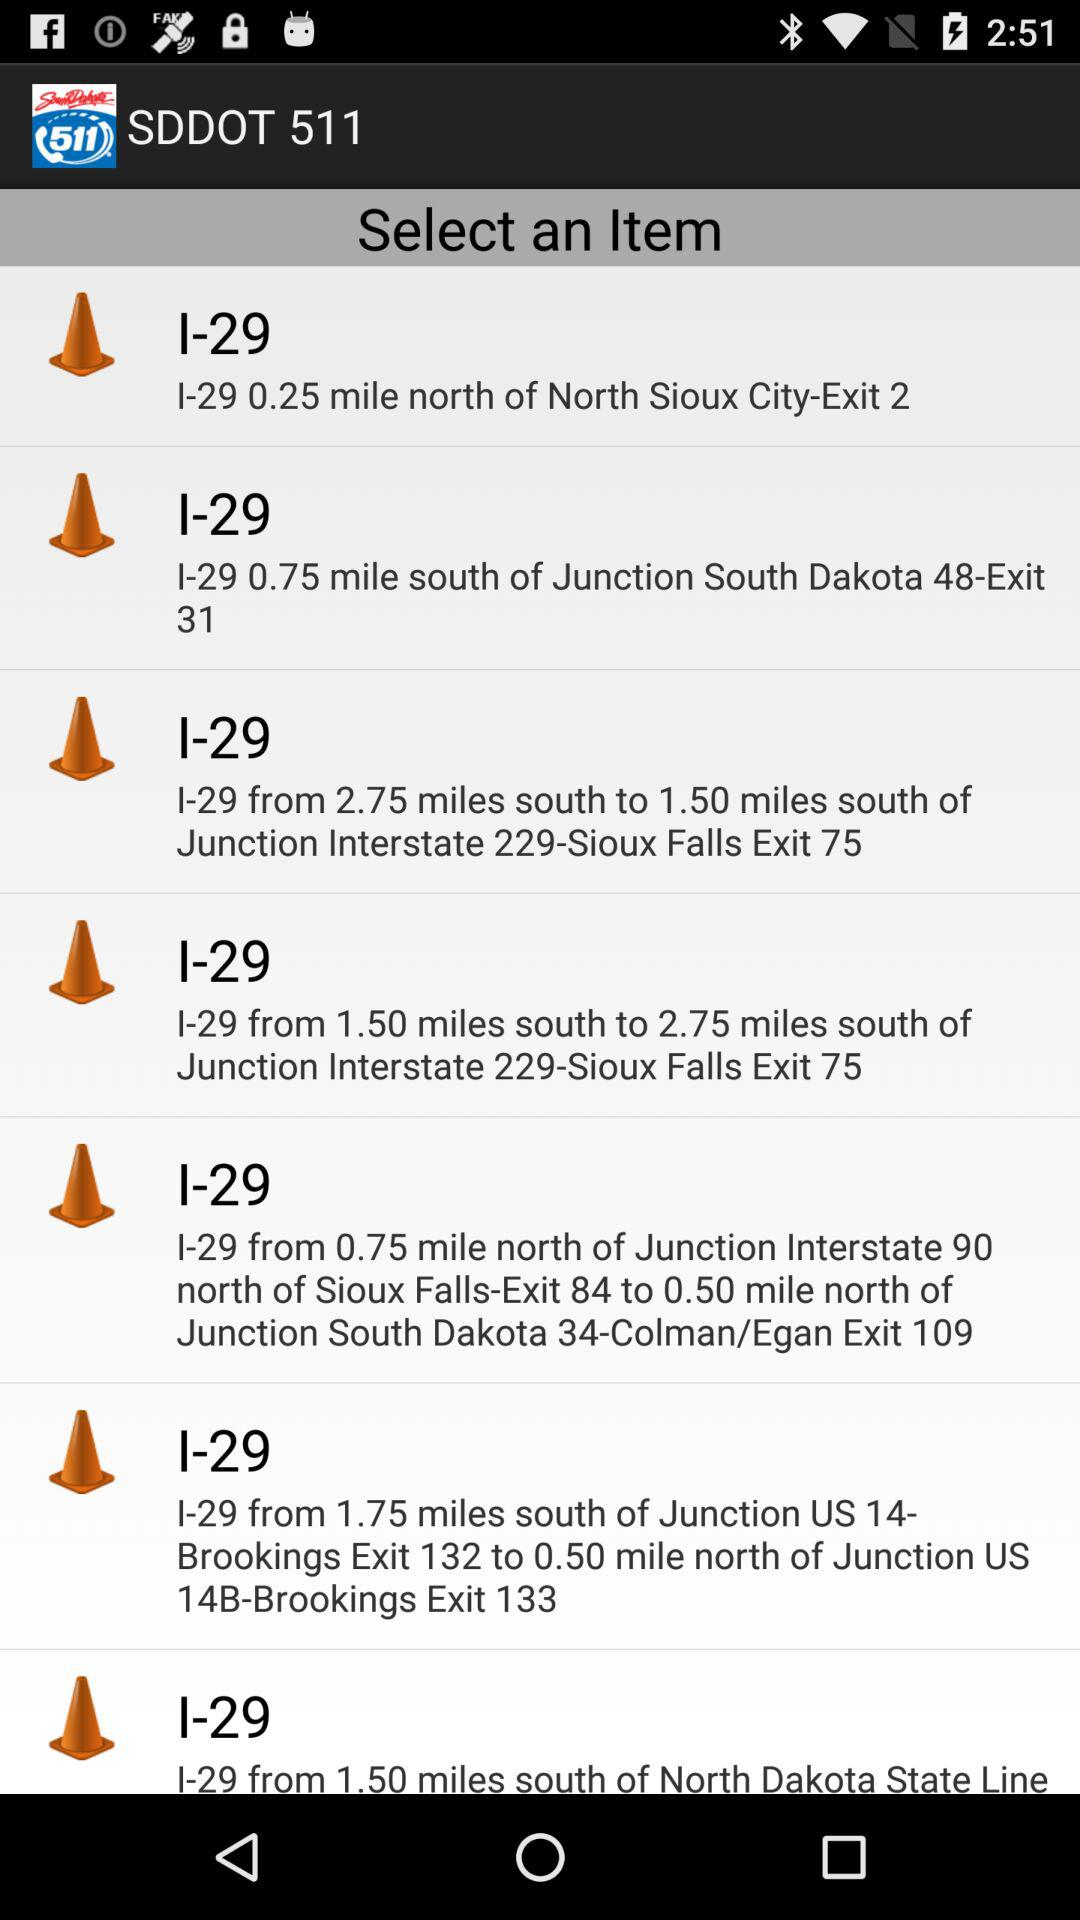What is the distance between Brookings Exit 132 and l-29? The distance between Brookings Exit 132 and l-29 is 1.75 miles. 